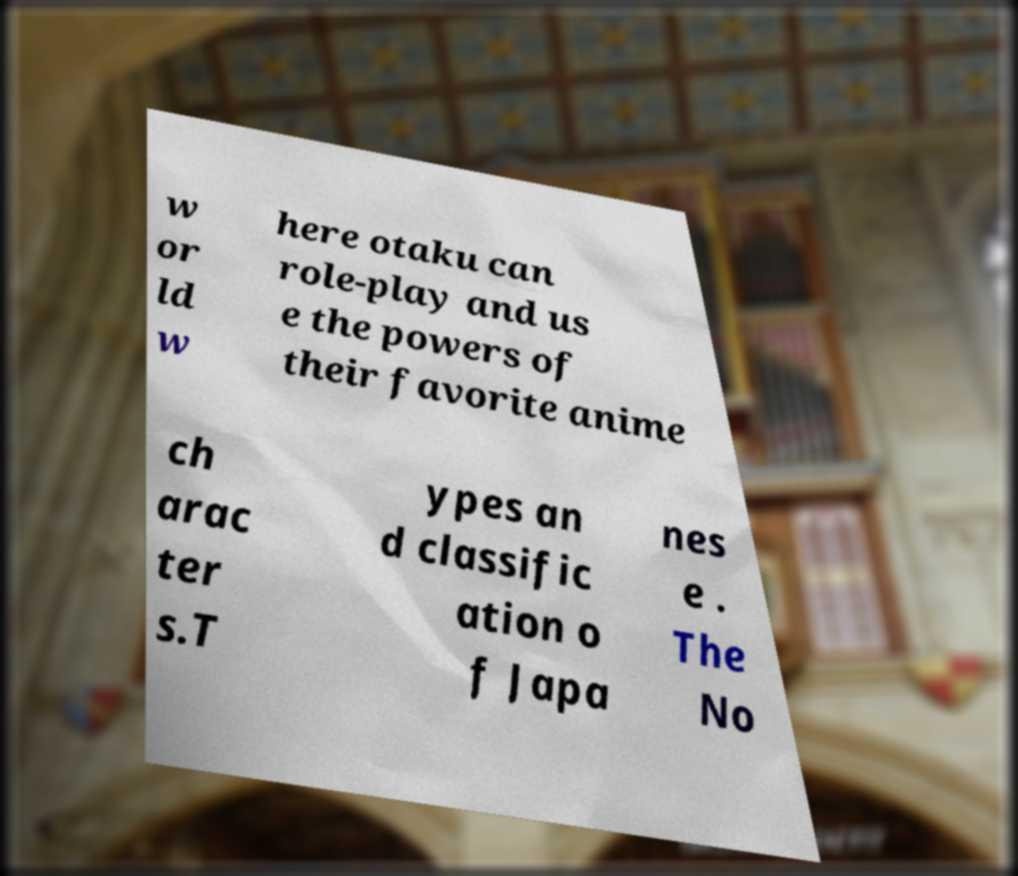Can you accurately transcribe the text from the provided image for me? w or ld w here otaku can role-play and us e the powers of their favorite anime ch arac ter s.T ypes an d classific ation o f Japa nes e . The No 